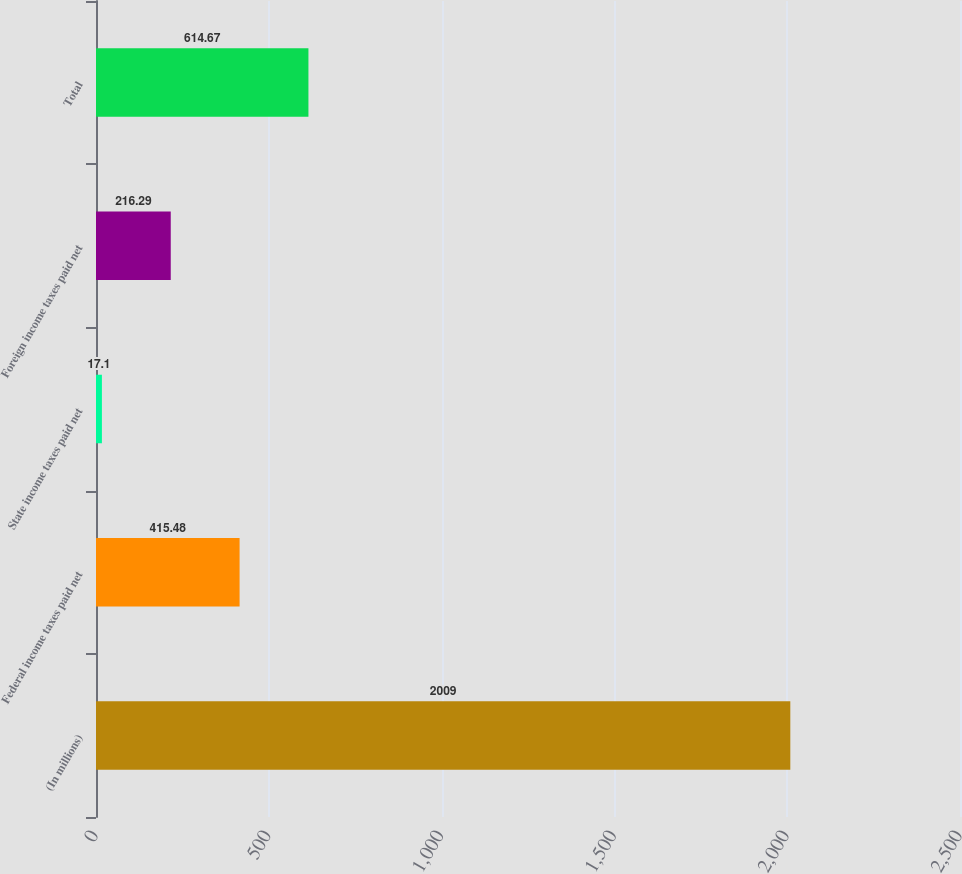Convert chart. <chart><loc_0><loc_0><loc_500><loc_500><bar_chart><fcel>(In millions)<fcel>Federal income taxes paid net<fcel>State income taxes paid net<fcel>Foreign income taxes paid net<fcel>Total<nl><fcel>2009<fcel>415.48<fcel>17.1<fcel>216.29<fcel>614.67<nl></chart> 